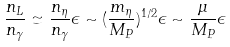<formula> <loc_0><loc_0><loc_500><loc_500>\frac { n _ { L } } { n _ { \gamma } } \simeq \frac { n _ { \eta } } { n _ { \gamma } } \epsilon \sim ( \frac { m _ { \eta } } { M _ { P } } ) ^ { 1 / 2 } \epsilon \sim \frac { \mu } { M _ { P } } \epsilon</formula> 